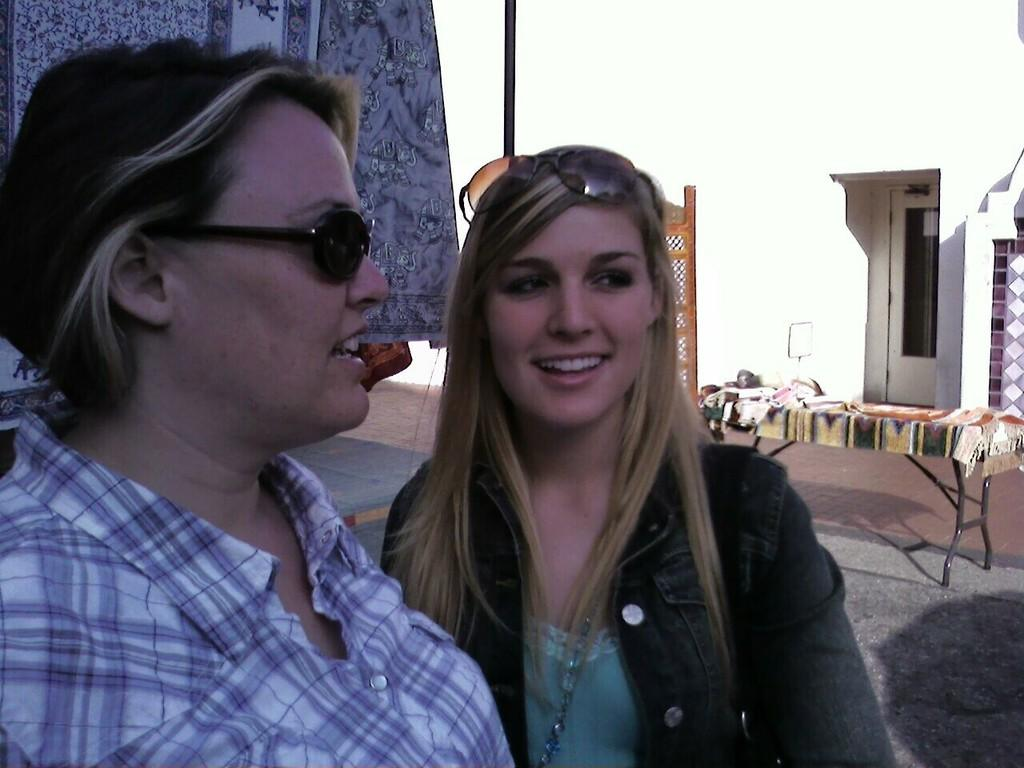How many people are present in the image? There are two persons in the image. What is visible in the background of the image? There is a table in the background of the image. What can be seen on the table in the background? There are objects on the table in the background of the image. What month is depicted in the image? There is no indication of a specific month in the image. How is the distribution of objects on the table managed in the image? The image does not show any distribution of objects on the table; it only shows their presence. 